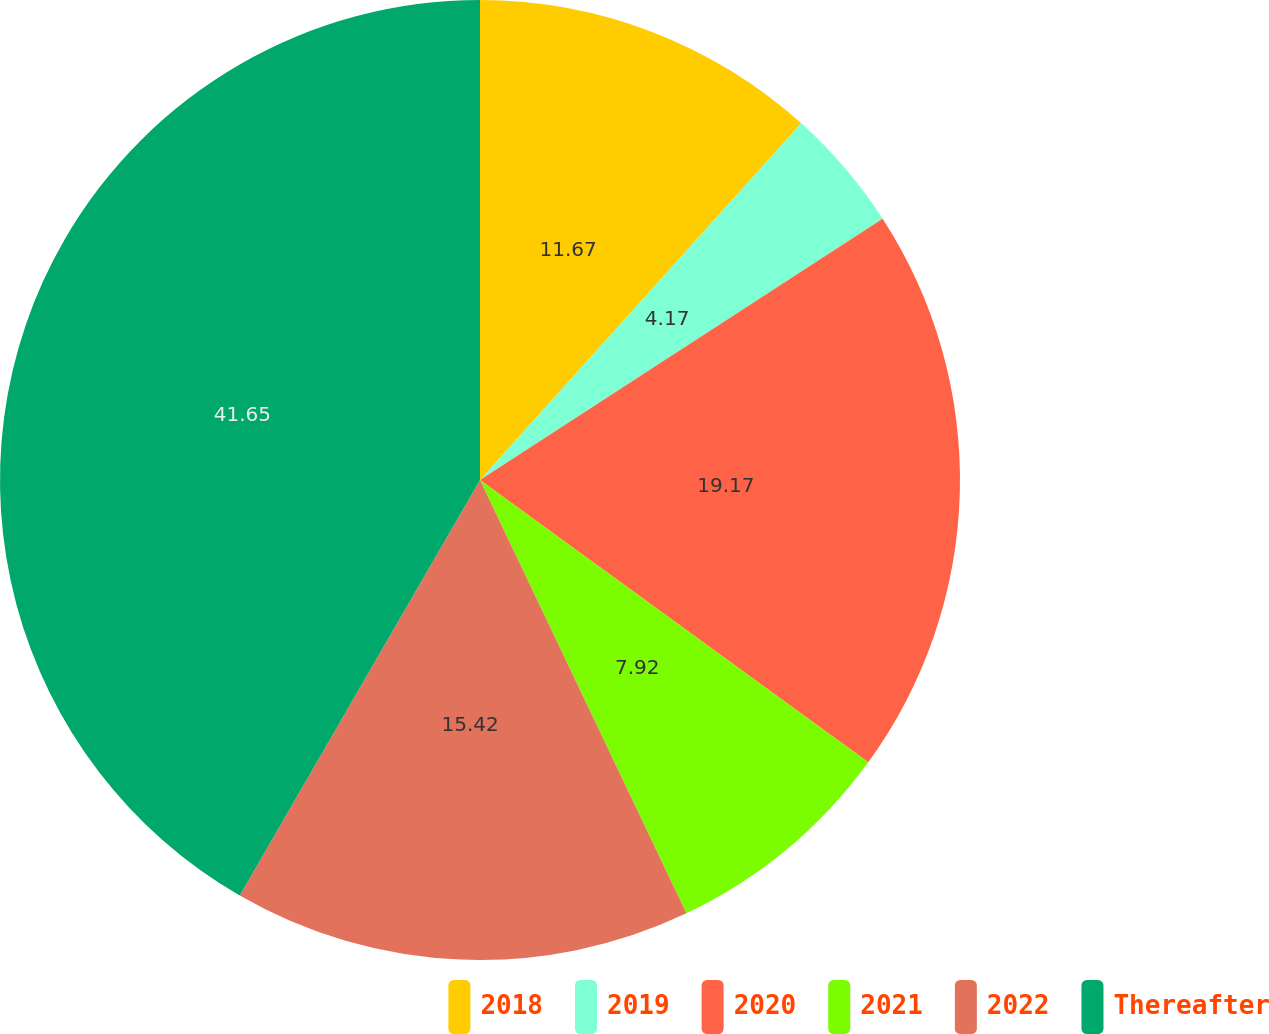Convert chart. <chart><loc_0><loc_0><loc_500><loc_500><pie_chart><fcel>2018<fcel>2019<fcel>2020<fcel>2021<fcel>2022<fcel>Thereafter<nl><fcel>11.67%<fcel>4.17%<fcel>19.17%<fcel>7.92%<fcel>15.42%<fcel>41.66%<nl></chart> 